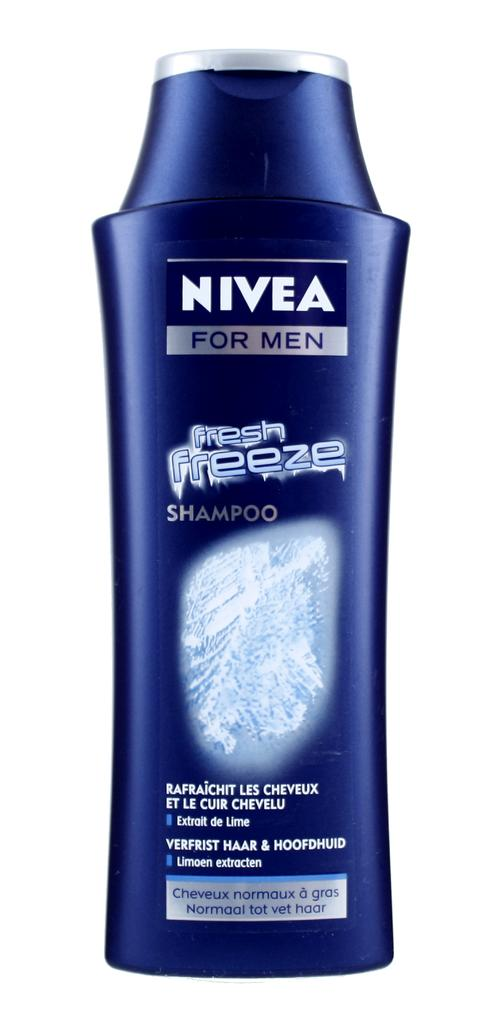<image>
Write a terse but informative summary of the picture. Blue bottle of Nivea for men in front of a white background. 